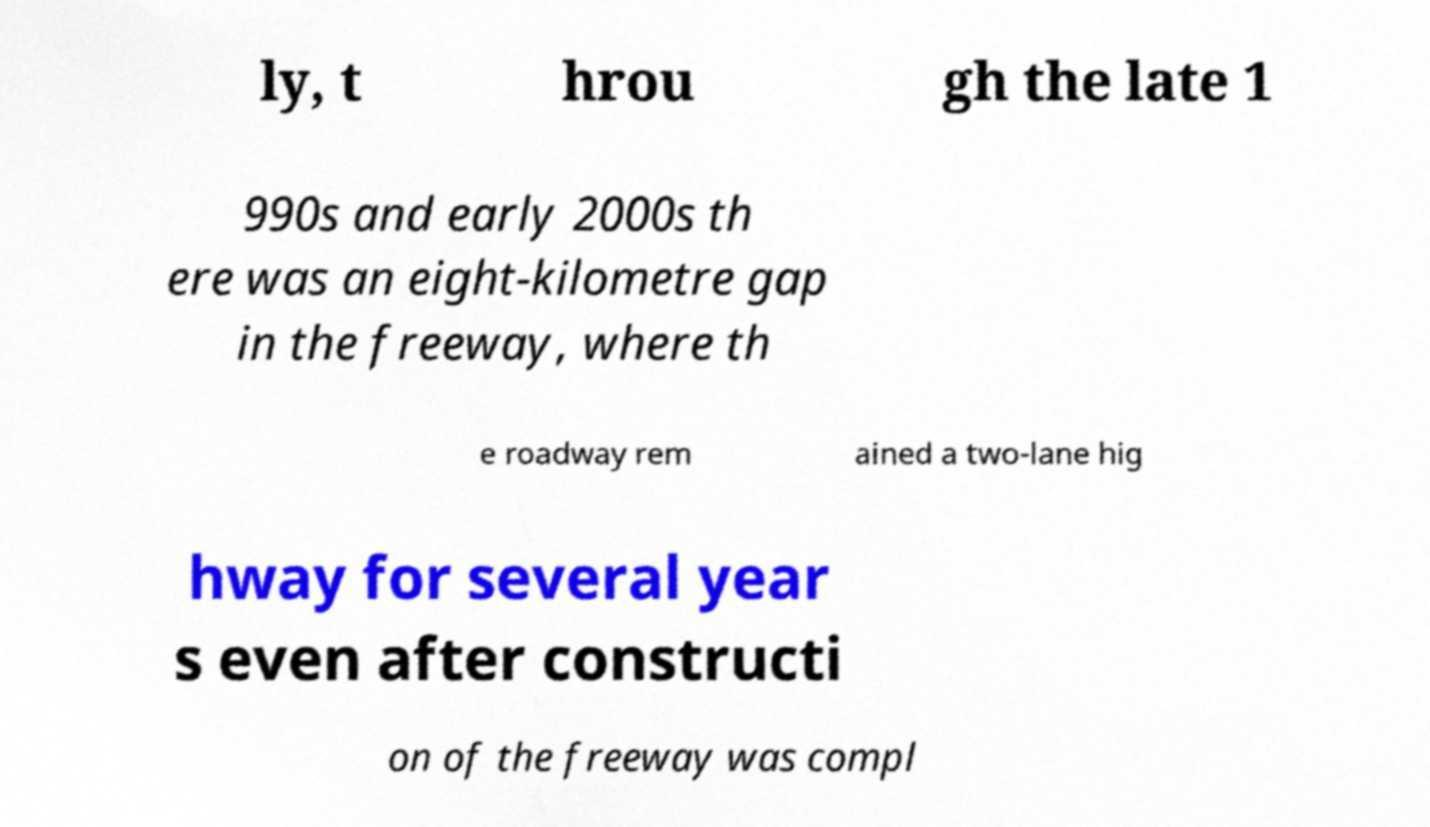I need the written content from this picture converted into text. Can you do that? ly, t hrou gh the late 1 990s and early 2000s th ere was an eight-kilometre gap in the freeway, where th e roadway rem ained a two-lane hig hway for several year s even after constructi on of the freeway was compl 